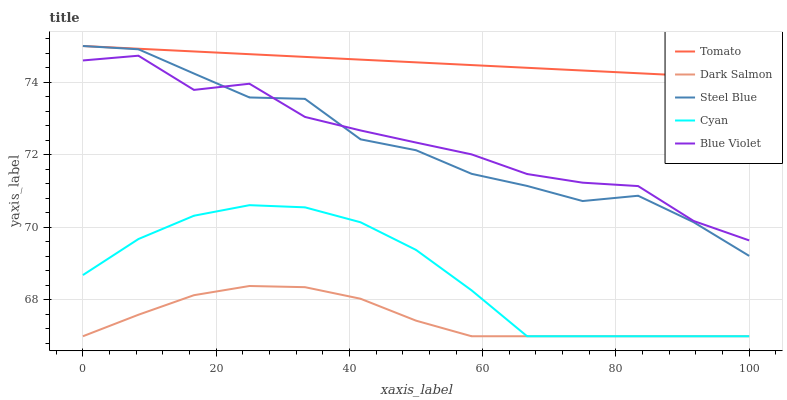Does Dark Salmon have the minimum area under the curve?
Answer yes or no. Yes. Does Tomato have the maximum area under the curve?
Answer yes or no. Yes. Does Cyan have the minimum area under the curve?
Answer yes or no. No. Does Cyan have the maximum area under the curve?
Answer yes or no. No. Is Tomato the smoothest?
Answer yes or no. Yes. Is Blue Violet the roughest?
Answer yes or no. Yes. Is Cyan the smoothest?
Answer yes or no. No. Is Cyan the roughest?
Answer yes or no. No. Does Blue Violet have the lowest value?
Answer yes or no. No. Does Cyan have the highest value?
Answer yes or no. No. Is Dark Salmon less than Tomato?
Answer yes or no. Yes. Is Steel Blue greater than Dark Salmon?
Answer yes or no. Yes. Does Dark Salmon intersect Tomato?
Answer yes or no. No. 